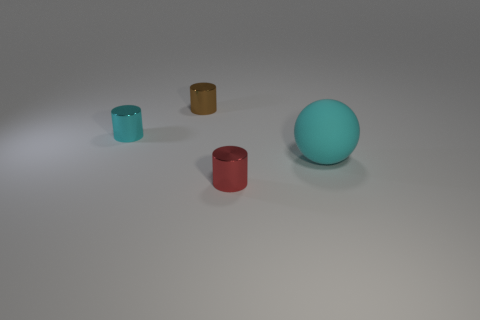Add 1 small cyan metal balls. How many objects exist? 5 Subtract all balls. How many objects are left? 3 Add 3 cylinders. How many cylinders exist? 6 Subtract 0 brown blocks. How many objects are left? 4 Subtract all small red balls. Subtract all balls. How many objects are left? 3 Add 1 spheres. How many spheres are left? 2 